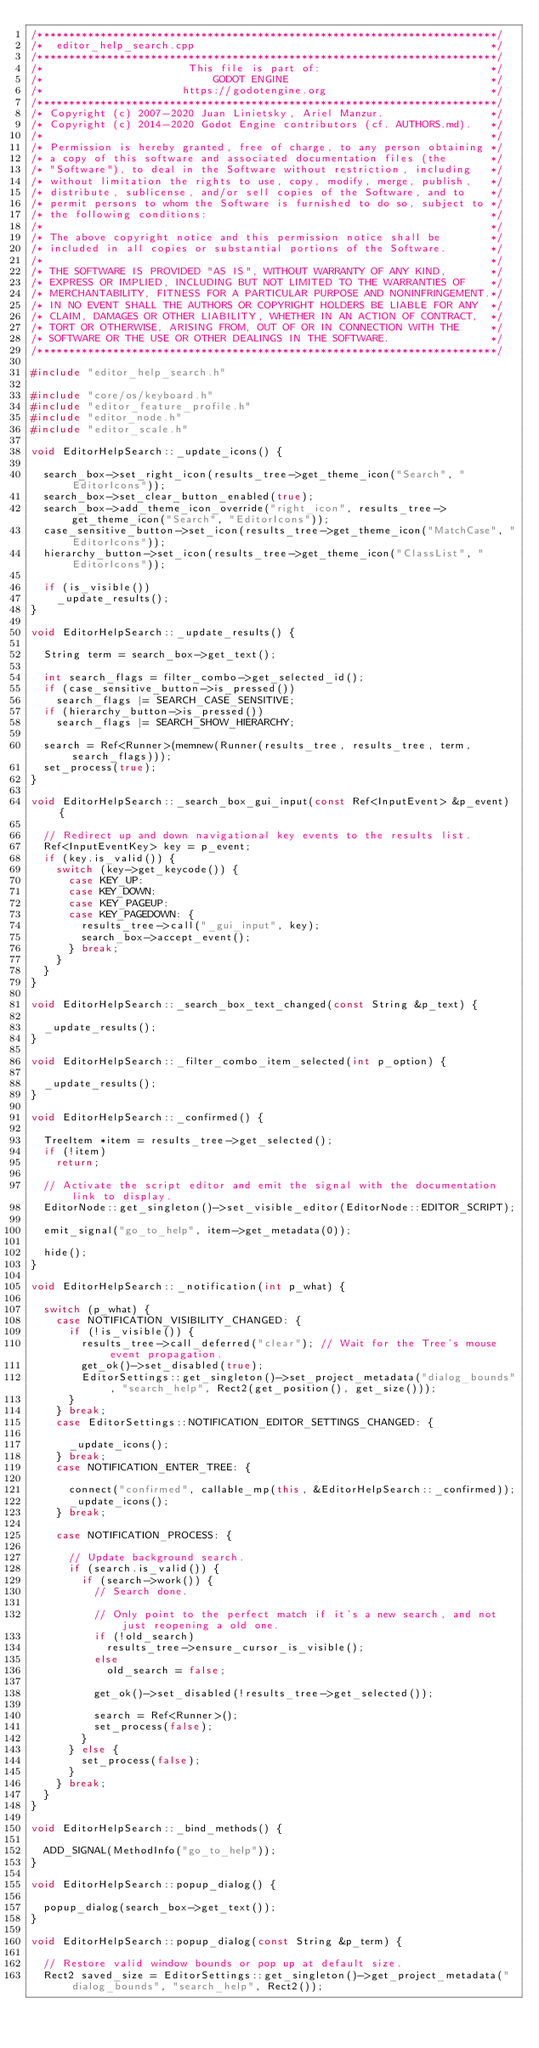Convert code to text. <code><loc_0><loc_0><loc_500><loc_500><_C++_>/*************************************************************************/
/*  editor_help_search.cpp                                               */
/*************************************************************************/
/*                       This file is part of:                           */
/*                           GODOT ENGINE                                */
/*                      https://godotengine.org                          */
/*************************************************************************/
/* Copyright (c) 2007-2020 Juan Linietsky, Ariel Manzur.                 */
/* Copyright (c) 2014-2020 Godot Engine contributors (cf. AUTHORS.md).   */
/*                                                                       */
/* Permission is hereby granted, free of charge, to any person obtaining */
/* a copy of this software and associated documentation files (the       */
/* "Software"), to deal in the Software without restriction, including   */
/* without limitation the rights to use, copy, modify, merge, publish,   */
/* distribute, sublicense, and/or sell copies of the Software, and to    */
/* permit persons to whom the Software is furnished to do so, subject to */
/* the following conditions:                                             */
/*                                                                       */
/* The above copyright notice and this permission notice shall be        */
/* included in all copies or substantial portions of the Software.       */
/*                                                                       */
/* THE SOFTWARE IS PROVIDED "AS IS", WITHOUT WARRANTY OF ANY KIND,       */
/* EXPRESS OR IMPLIED, INCLUDING BUT NOT LIMITED TO THE WARRANTIES OF    */
/* MERCHANTABILITY, FITNESS FOR A PARTICULAR PURPOSE AND NONINFRINGEMENT.*/
/* IN NO EVENT SHALL THE AUTHORS OR COPYRIGHT HOLDERS BE LIABLE FOR ANY  */
/* CLAIM, DAMAGES OR OTHER LIABILITY, WHETHER IN AN ACTION OF CONTRACT,  */
/* TORT OR OTHERWISE, ARISING FROM, OUT OF OR IN CONNECTION WITH THE     */
/* SOFTWARE OR THE USE OR OTHER DEALINGS IN THE SOFTWARE.                */
/*************************************************************************/

#include "editor_help_search.h"

#include "core/os/keyboard.h"
#include "editor_feature_profile.h"
#include "editor_node.h"
#include "editor_scale.h"

void EditorHelpSearch::_update_icons() {

	search_box->set_right_icon(results_tree->get_theme_icon("Search", "EditorIcons"));
	search_box->set_clear_button_enabled(true);
	search_box->add_theme_icon_override("right_icon", results_tree->get_theme_icon("Search", "EditorIcons"));
	case_sensitive_button->set_icon(results_tree->get_theme_icon("MatchCase", "EditorIcons"));
	hierarchy_button->set_icon(results_tree->get_theme_icon("ClassList", "EditorIcons"));

	if (is_visible())
		_update_results();
}

void EditorHelpSearch::_update_results() {

	String term = search_box->get_text();

	int search_flags = filter_combo->get_selected_id();
	if (case_sensitive_button->is_pressed())
		search_flags |= SEARCH_CASE_SENSITIVE;
	if (hierarchy_button->is_pressed())
		search_flags |= SEARCH_SHOW_HIERARCHY;

	search = Ref<Runner>(memnew(Runner(results_tree, results_tree, term, search_flags)));
	set_process(true);
}

void EditorHelpSearch::_search_box_gui_input(const Ref<InputEvent> &p_event) {

	// Redirect up and down navigational key events to the results list.
	Ref<InputEventKey> key = p_event;
	if (key.is_valid()) {
		switch (key->get_keycode()) {
			case KEY_UP:
			case KEY_DOWN:
			case KEY_PAGEUP:
			case KEY_PAGEDOWN: {
				results_tree->call("_gui_input", key);
				search_box->accept_event();
			} break;
		}
	}
}

void EditorHelpSearch::_search_box_text_changed(const String &p_text) {

	_update_results();
}

void EditorHelpSearch::_filter_combo_item_selected(int p_option) {

	_update_results();
}

void EditorHelpSearch::_confirmed() {

	TreeItem *item = results_tree->get_selected();
	if (!item)
		return;

	// Activate the script editor and emit the signal with the documentation link to display.
	EditorNode::get_singleton()->set_visible_editor(EditorNode::EDITOR_SCRIPT);

	emit_signal("go_to_help", item->get_metadata(0));

	hide();
}

void EditorHelpSearch::_notification(int p_what) {

	switch (p_what) {
		case NOTIFICATION_VISIBILITY_CHANGED: {
			if (!is_visible()) {
				results_tree->call_deferred("clear"); // Wait for the Tree's mouse event propagation.
				get_ok()->set_disabled(true);
				EditorSettings::get_singleton()->set_project_metadata("dialog_bounds", "search_help", Rect2(get_position(), get_size()));
			}
		} break;
		case EditorSettings::NOTIFICATION_EDITOR_SETTINGS_CHANGED: {

			_update_icons();
		} break;
		case NOTIFICATION_ENTER_TREE: {

			connect("confirmed", callable_mp(this, &EditorHelpSearch::_confirmed));
			_update_icons();
		} break;

		case NOTIFICATION_PROCESS: {

			// Update background search.
			if (search.is_valid()) {
				if (search->work()) {
					// Search done.

					// Only point to the perfect match if it's a new search, and not just reopening a old one.
					if (!old_search)
						results_tree->ensure_cursor_is_visible();
					else
						old_search = false;

					get_ok()->set_disabled(!results_tree->get_selected());

					search = Ref<Runner>();
					set_process(false);
				}
			} else {
				set_process(false);
			}
		} break;
	}
}

void EditorHelpSearch::_bind_methods() {

	ADD_SIGNAL(MethodInfo("go_to_help"));
}

void EditorHelpSearch::popup_dialog() {

	popup_dialog(search_box->get_text());
}

void EditorHelpSearch::popup_dialog(const String &p_term) {

	// Restore valid window bounds or pop up at default size.
	Rect2 saved_size = EditorSettings::get_singleton()->get_project_metadata("dialog_bounds", "search_help", Rect2());</code> 